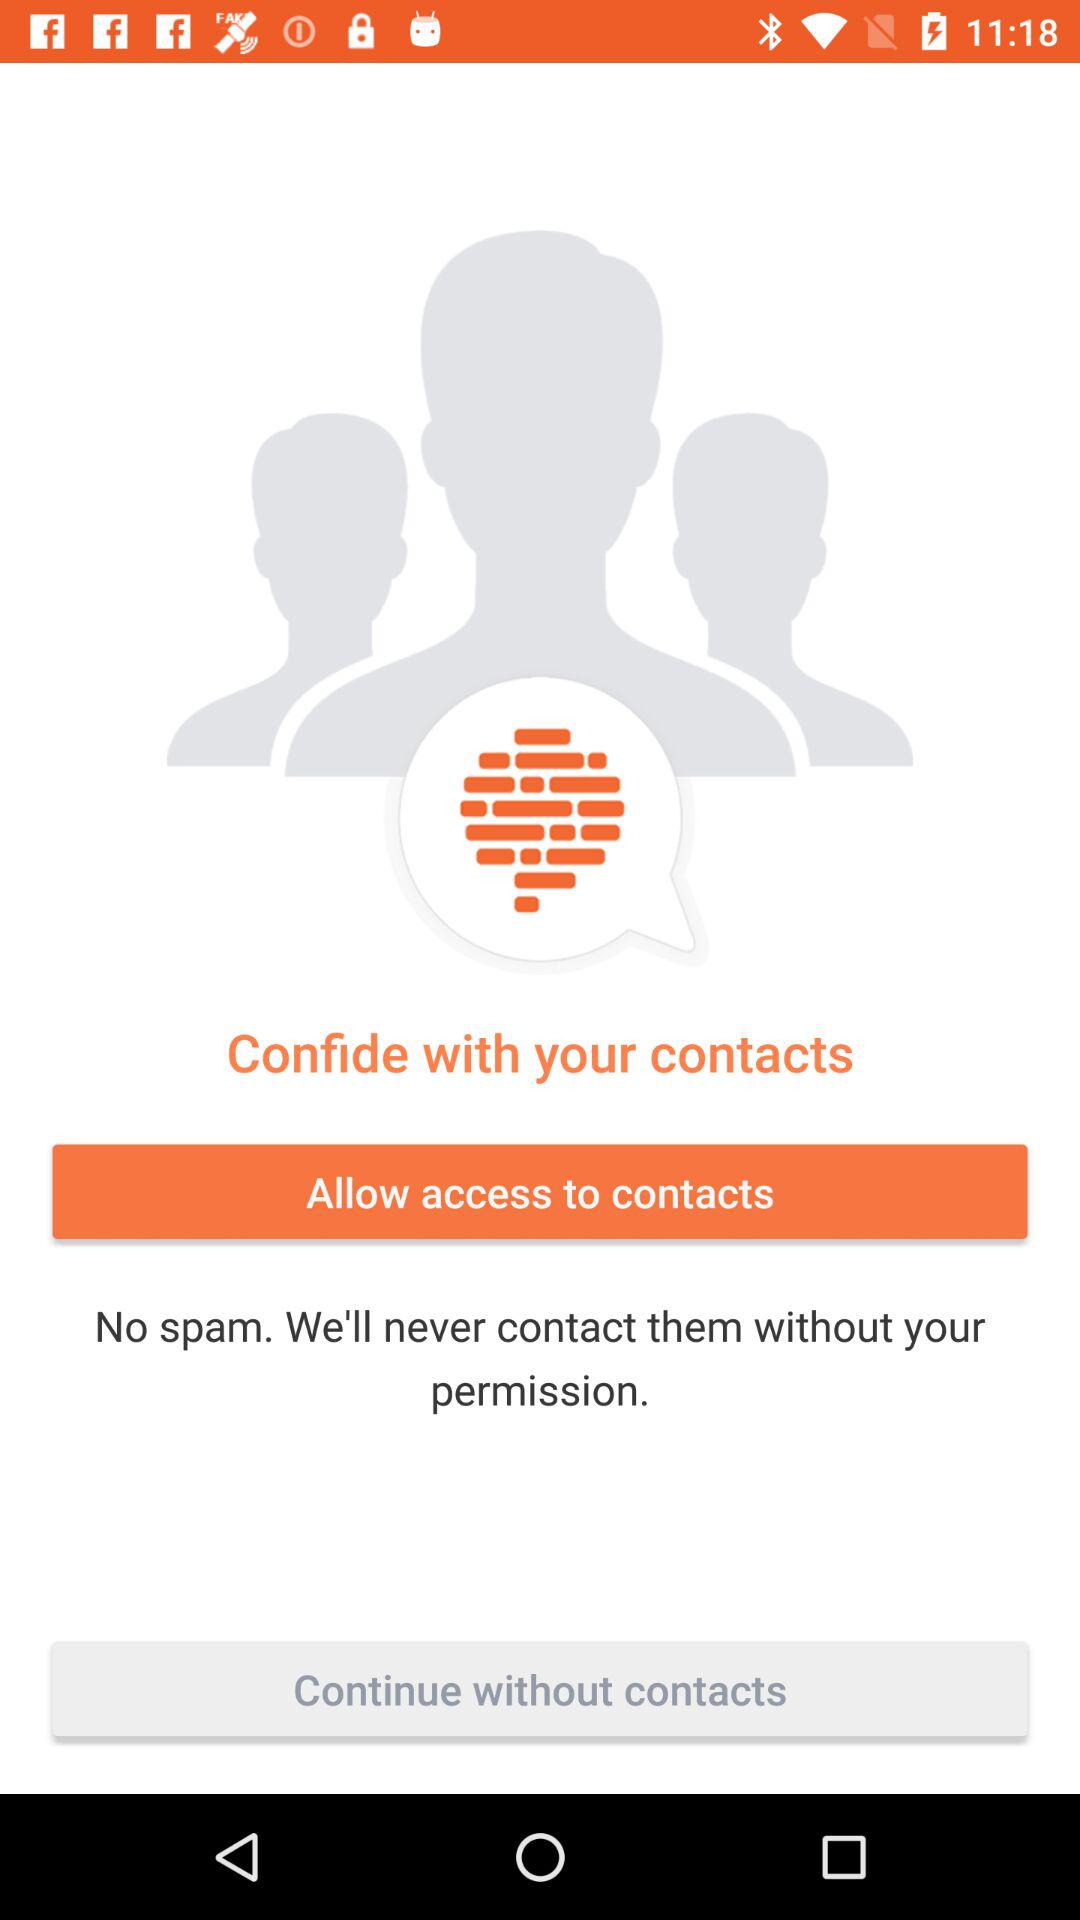To whom should I allow access? You should allow access to contacts. 